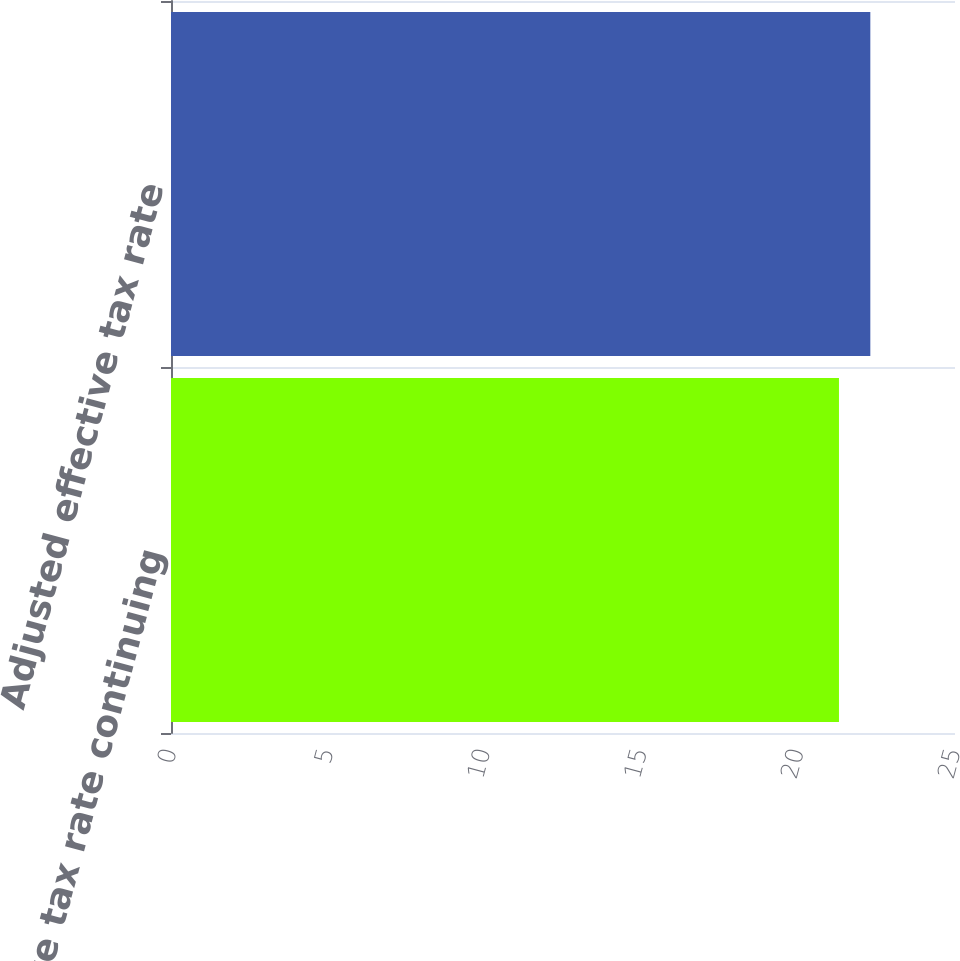Convert chart. <chart><loc_0><loc_0><loc_500><loc_500><bar_chart><fcel>Effective tax rate continuing<fcel>Adjusted effective tax rate<nl><fcel>21.3<fcel>22.3<nl></chart> 